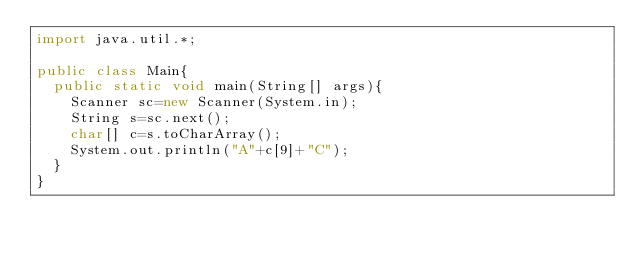<code> <loc_0><loc_0><loc_500><loc_500><_Java_>import java.util.*;

public class Main{
  public static void main(String[] args){
    Scanner sc=new Scanner(System.in);
    String s=sc.next();
    char[] c=s.toCharArray();
    System.out.println("A"+c[9]+"C");
  }
}</code> 